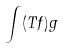Convert formula to latex. <formula><loc_0><loc_0><loc_500><loc_500>\int ( T f ) g</formula> 